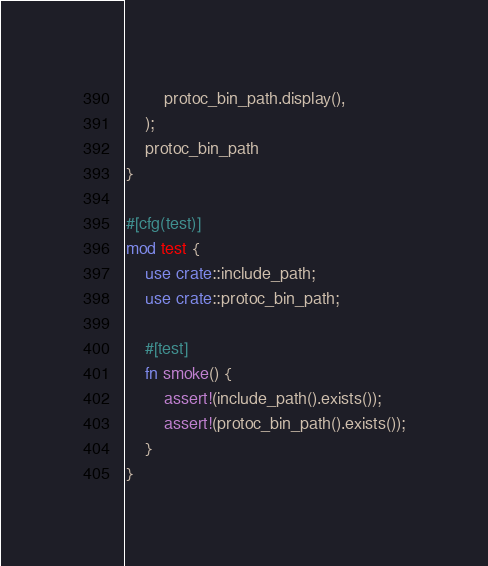Convert code to text. <code><loc_0><loc_0><loc_500><loc_500><_Rust_>        protoc_bin_path.display(),
    );
    protoc_bin_path
}

#[cfg(test)]
mod test {
    use crate::include_path;
    use crate::protoc_bin_path;

    #[test]
    fn smoke() {
        assert!(include_path().exists());
        assert!(protoc_bin_path().exists());
    }
}
</code> 